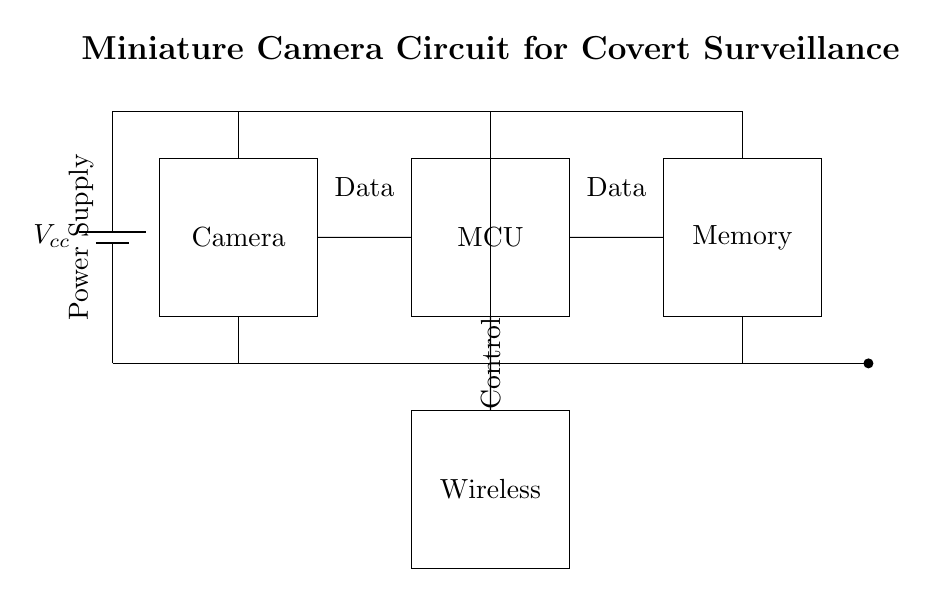What is the main component for capturing images? The main component for capturing images is the camera module, which is clearly labeled in the circuit diagram as "Camera." This component is responsible for the actual video or image capture needed in surveillance operations.
Answer: Camera What is the power supply voltage in this circuit? The power supply voltage is indicated by the term "Vcc," which is a common notation for input voltage. While the specific voltage isn't given in the diagram, it typically represents a supply voltage that powers the entire system.
Answer: Vcc How many data connections are shown in the circuit? There are two distinct data connections indicated in the circuit diagram: one connection from the camera to the microcontroller and another from the microcontroller to the memory. The arrangement provides a clear pathway for data to flow from image capture to storage.
Answer: Two What does the MCU stand for? The term "MCU" in the circuit diagram stands for Microcontroller Unit, which is a crucial component that manages the processing of data from the camera and directs it to other parts like memory and wireless modules.
Answer: Microcontroller Unit Which component handles wireless communication? The component that handles wireless communication is labeled as "Wireless" in the circuit. This suggests that it is responsible for transmitting the data captured by the camera remotely, facilitating covert operations.
Answer: Wireless Why is memory included in this circuit? Memory is included in this circuit to store the captured images or video data temporarily or permanently. It allows the information gathered by the camera to be accessible for retrieval or playback, thus playing a key role in surveillance tasks.
Answer: Storage of data What type of circuit is represented here? The type of circuit represented here is a miniature camera circuit specifically designed for covert surveillance operations. Its layout and components are tailored to meet the needs of stealthy capturing and transmitting visual data.
Answer: Miniature camera circuit 